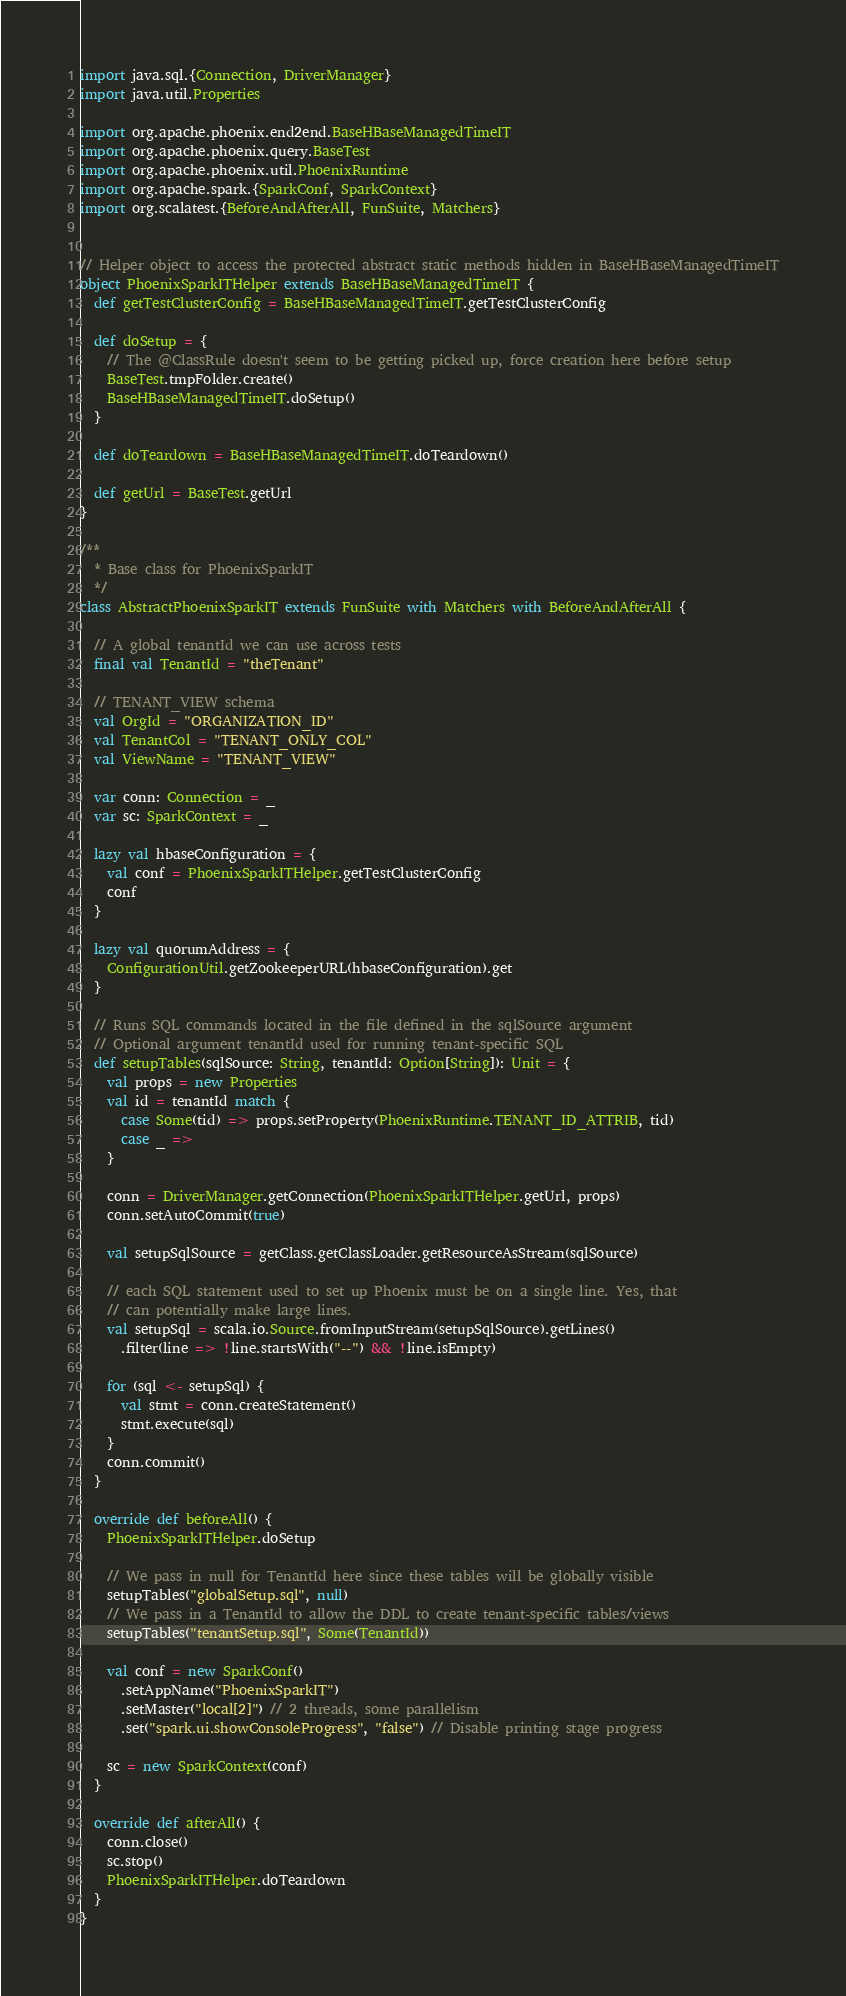<code> <loc_0><loc_0><loc_500><loc_500><_Scala_>import java.sql.{Connection, DriverManager}
import java.util.Properties

import org.apache.phoenix.end2end.BaseHBaseManagedTimeIT
import org.apache.phoenix.query.BaseTest
import org.apache.phoenix.util.PhoenixRuntime
import org.apache.spark.{SparkConf, SparkContext}
import org.scalatest.{BeforeAndAfterAll, FunSuite, Matchers}


// Helper object to access the protected abstract static methods hidden in BaseHBaseManagedTimeIT
object PhoenixSparkITHelper extends BaseHBaseManagedTimeIT {
  def getTestClusterConfig = BaseHBaseManagedTimeIT.getTestClusterConfig

  def doSetup = {
    // The @ClassRule doesn't seem to be getting picked up, force creation here before setup
    BaseTest.tmpFolder.create()
    BaseHBaseManagedTimeIT.doSetup()
  }

  def doTeardown = BaseHBaseManagedTimeIT.doTeardown()

  def getUrl = BaseTest.getUrl
}

/**
  * Base class for PhoenixSparkIT
  */
class AbstractPhoenixSparkIT extends FunSuite with Matchers with BeforeAndAfterAll {

  // A global tenantId we can use across tests
  final val TenantId = "theTenant"

  // TENANT_VIEW schema
  val OrgId = "ORGANIZATION_ID"
  val TenantCol = "TENANT_ONLY_COL"
  val ViewName = "TENANT_VIEW"

  var conn: Connection = _
  var sc: SparkContext = _

  lazy val hbaseConfiguration = {
    val conf = PhoenixSparkITHelper.getTestClusterConfig
    conf
  }

  lazy val quorumAddress = {
    ConfigurationUtil.getZookeeperURL(hbaseConfiguration).get
  }

  // Runs SQL commands located in the file defined in the sqlSource argument
  // Optional argument tenantId used for running tenant-specific SQL
  def setupTables(sqlSource: String, tenantId: Option[String]): Unit = {
    val props = new Properties
    val id = tenantId match {
      case Some(tid) => props.setProperty(PhoenixRuntime.TENANT_ID_ATTRIB, tid)
      case _ =>
    }

    conn = DriverManager.getConnection(PhoenixSparkITHelper.getUrl, props)
    conn.setAutoCommit(true)

    val setupSqlSource = getClass.getClassLoader.getResourceAsStream(sqlSource)

    // each SQL statement used to set up Phoenix must be on a single line. Yes, that
    // can potentially make large lines.
    val setupSql = scala.io.Source.fromInputStream(setupSqlSource).getLines()
      .filter(line => !line.startsWith("--") && !line.isEmpty)

    for (sql <- setupSql) {
      val stmt = conn.createStatement()
      stmt.execute(sql)
    }
    conn.commit()
  }

  override def beforeAll() {
    PhoenixSparkITHelper.doSetup

    // We pass in null for TenantId here since these tables will be globally visible
    setupTables("globalSetup.sql", null)
    // We pass in a TenantId to allow the DDL to create tenant-specific tables/views
    setupTables("tenantSetup.sql", Some(TenantId))

    val conf = new SparkConf()
      .setAppName("PhoenixSparkIT")
      .setMaster("local[2]") // 2 threads, some parallelism
      .set("spark.ui.showConsoleProgress", "false") // Disable printing stage progress

    sc = new SparkContext(conf)
  }

  override def afterAll() {
    conn.close()
    sc.stop()
    PhoenixSparkITHelper.doTeardown
  }
}
</code> 